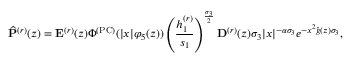<formula> <loc_0><loc_0><loc_500><loc_500>\widehat { P } ^ { ( r ) } ( z ) = E ^ { ( r ) } ( z ) \Phi ^ { ( P C ) } ( | x | \varphi _ { 5 } ( z ) ) \left ( \frac { h _ { 1 } ^ { ( r ) } } { s _ { 1 } } \right ) ^ { \frac { \sigma _ { 3 } } { 2 } } D ^ { ( r ) } ( z ) \sigma _ { 3 } | x | ^ { - \alpha \sigma _ { 3 } } e ^ { - x ^ { 2 } \widehat { g } ( z ) \sigma _ { 3 } } ,</formula> 